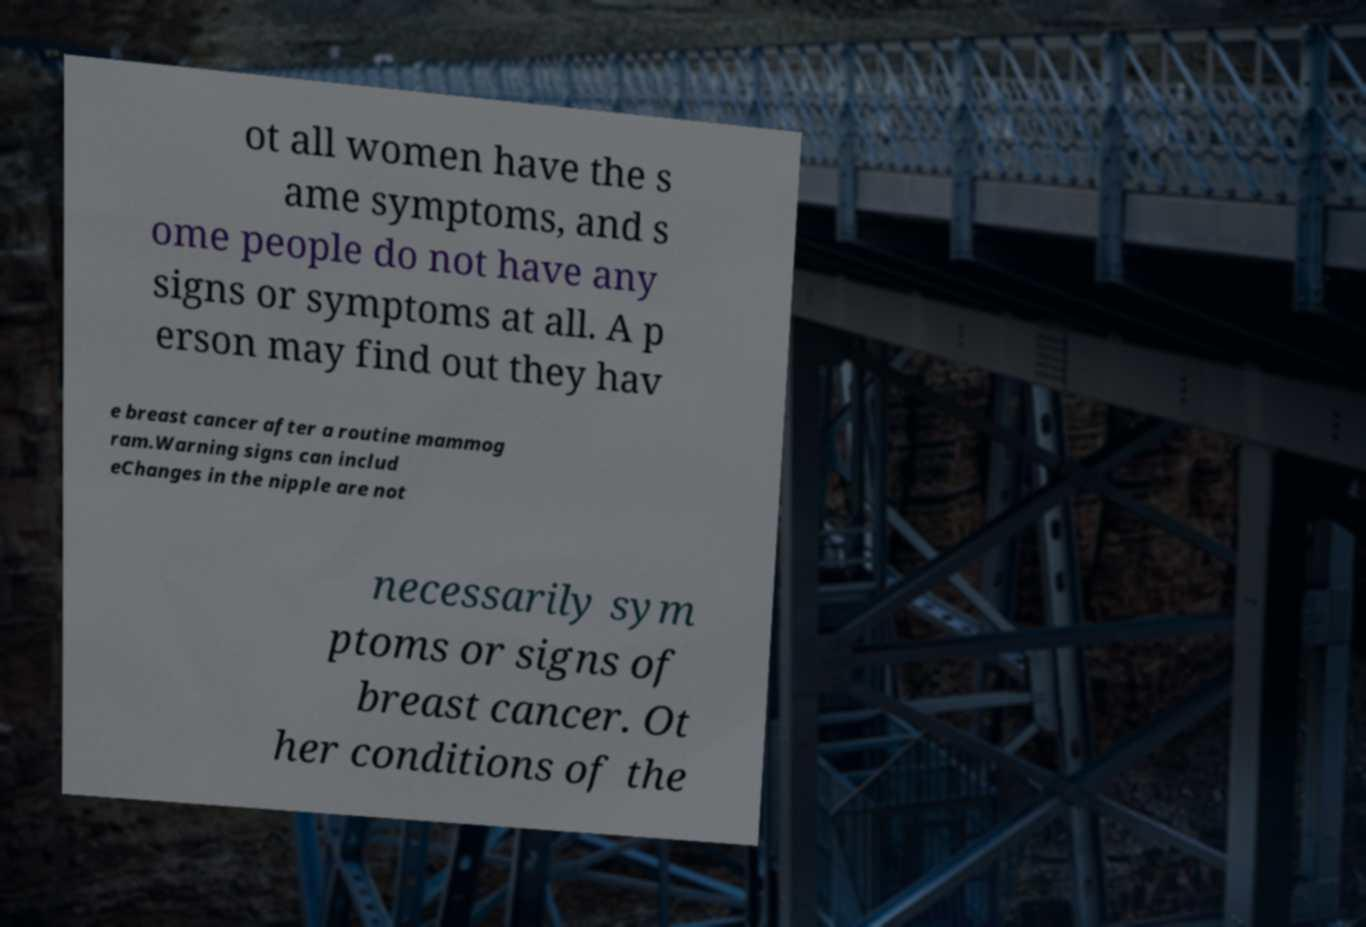I need the written content from this picture converted into text. Can you do that? ot all women have the s ame symptoms, and s ome people do not have any signs or symptoms at all. A p erson may find out they hav e breast cancer after a routine mammog ram.Warning signs can includ eChanges in the nipple are not necessarily sym ptoms or signs of breast cancer. Ot her conditions of the 